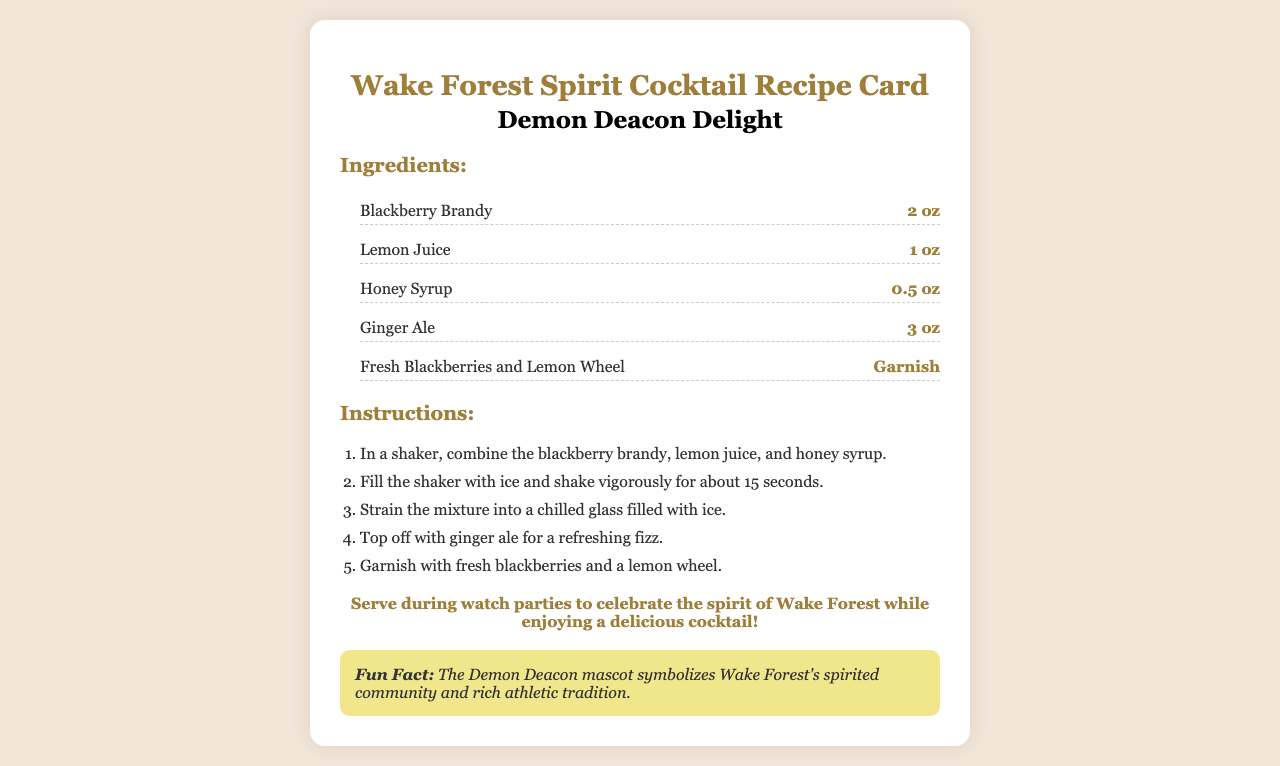What is the name of the cocktail? The name of the cocktail is clearly stated in the document under the title.
Answer: Demon Deacon Delight How many ounces of Blackberry Brandy are needed? The recipe specifies the amount of each ingredient in ounces, which can be found in the ingredients list.
Answer: 2 oz What is used to garnish the cocktail? The garnish is listed in the ingredients section, detailing what should be added for presentation.
Answer: Fresh Blackberries and Lemon Wheel How long should the mixture be shaken? The instructions for preparing the cocktail include a specific duration for shaking the mixture, which is important for proper blending.
Answer: 15 seconds What type of glass should the cocktail be served in? While the document does not specify a glass type explicitly, it implies the use of a chilled glass based on the preparation method.
Answer: Chilled glass What is the purpose of serving this cocktail? The serving suggestion highlights when the cocktail is appropriate to enjoy, which gives context to the recipe's theme.
Answer: Celebrate the spirit of Wake Forest How much Ginger Ale is included in the recipe? The amount of Ginger Ale is detailed in the ingredients list, adding to the overall mix of flavors in the cocktail.
Answer: 3 oz What color theme do the ingredients align with? The ingredients are inspired by Wake Forest's colors, which can be inferred from the combination of ingredients and their overall appearance.
Answer: Black and Gold What is a fun fact about the cocktail? The document includes a fun fact section that provides additional information related to the cocktail's theme.
Answer: The Demon Deacon mascot symbolizes Wake Forest's spirited community and rich athletic tradition 